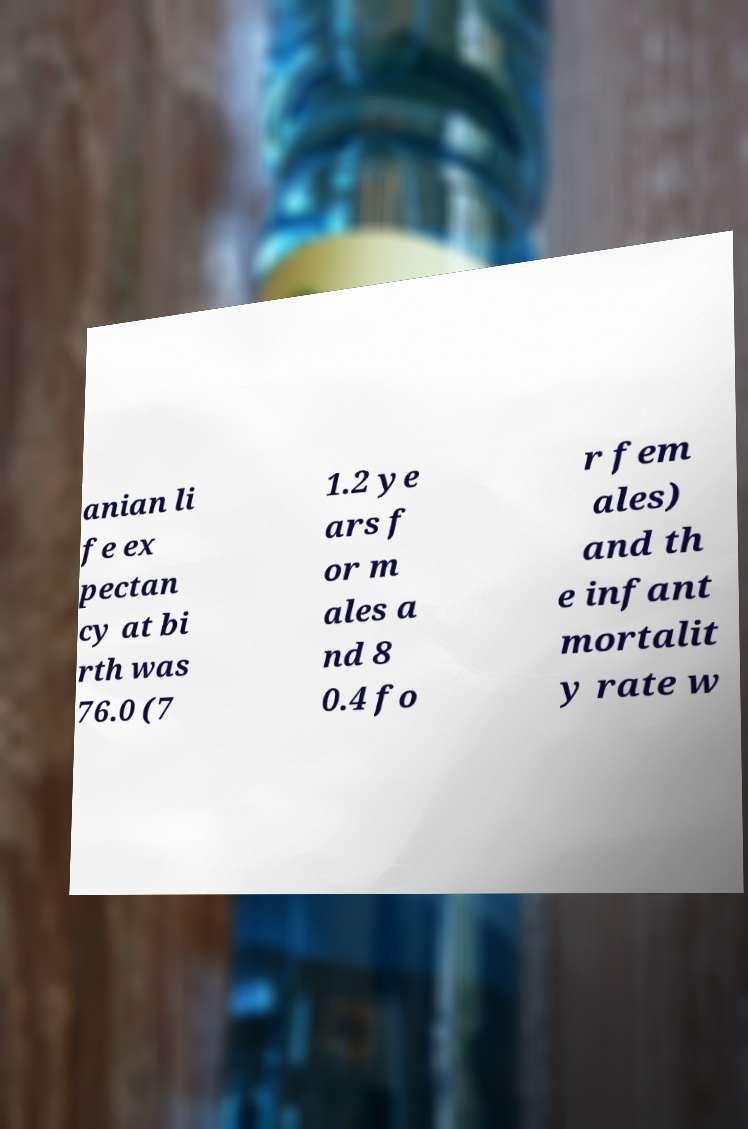Could you assist in decoding the text presented in this image and type it out clearly? anian li fe ex pectan cy at bi rth was 76.0 (7 1.2 ye ars f or m ales a nd 8 0.4 fo r fem ales) and th e infant mortalit y rate w 